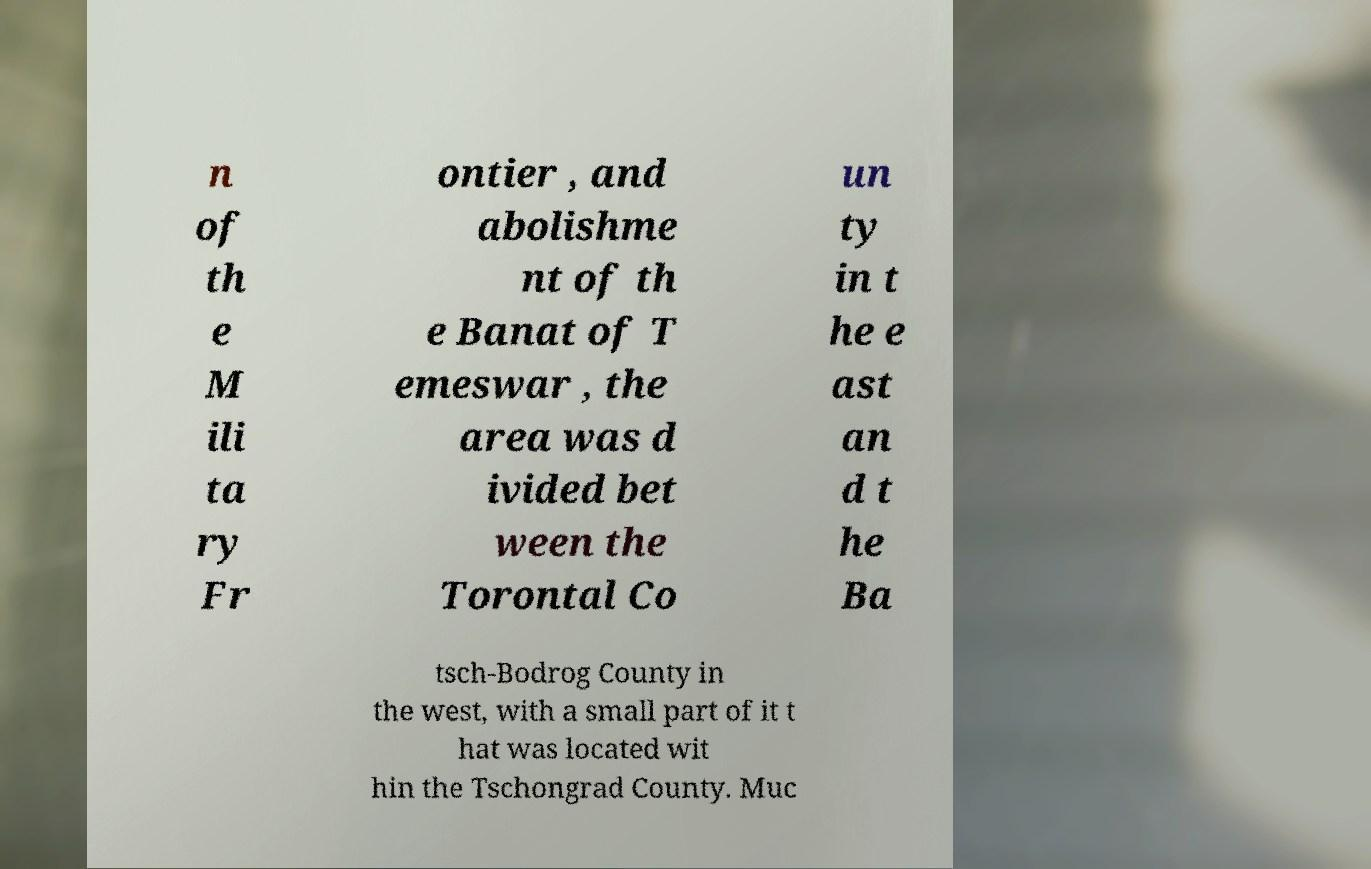Please identify and transcribe the text found in this image. n of th e M ili ta ry Fr ontier , and abolishme nt of th e Banat of T emeswar , the area was d ivided bet ween the Torontal Co un ty in t he e ast an d t he Ba tsch-Bodrog County in the west, with a small part of it t hat was located wit hin the Tschongrad County. Muc 